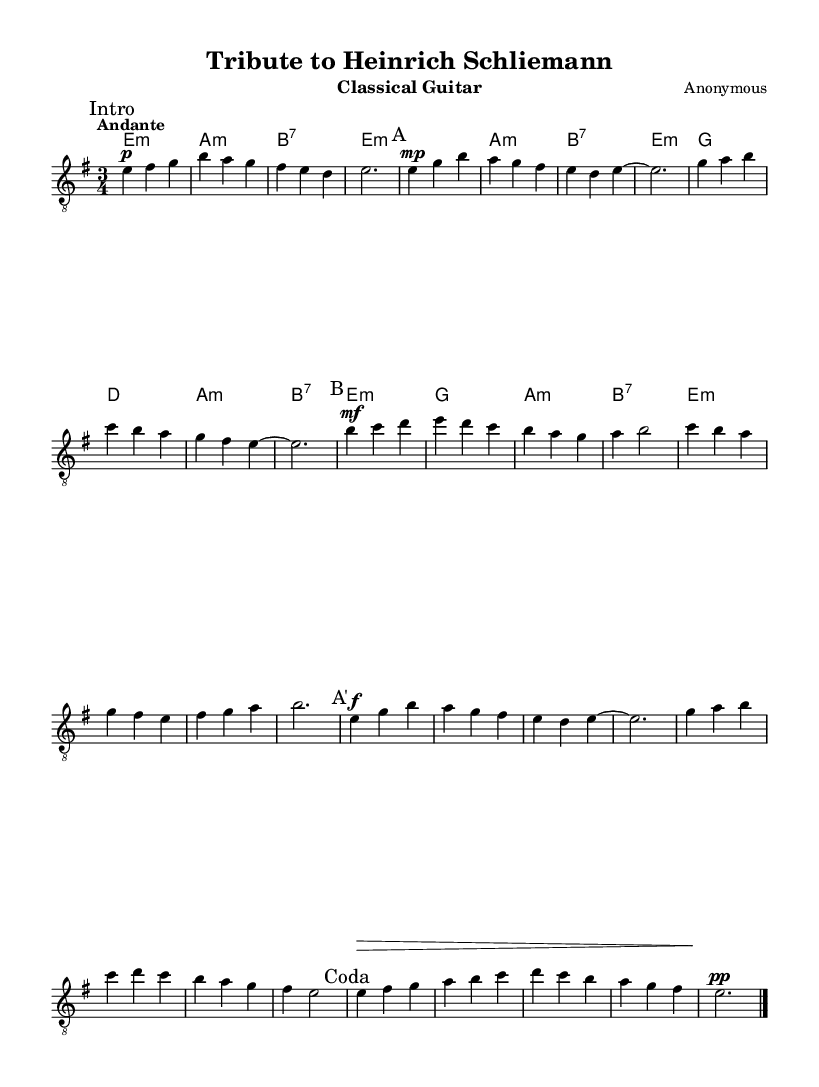What is the key signature of this music? The key signature is E minor, which has one sharp (F#). This is indicated at the beginning of the piece in the global settings.
Answer: E minor What is the time signature of this music? The time signature is 3/4, which means there are three beats in each measure with a quarter note getting the beat. This is shown in the global section as part of the settings.
Answer: 3/4 What is the tempo marking of this piece? The tempo marking is "Andante," which indicates a moderate walking pace. This is explicitly noted in the global settings under tempo.
Answer: Andante How many sections are there in this composition? There are four main sections: A, B, A', and Coda. Each section is marked in the music above the corresponding measures, providing clear labels for each part.
Answer: Four What dynamic marking appears at the beginning of the B section? The dynamic marking at the beginning of the B section is "mf," which stands for mezzo forte, indicating a moderately loud volume. This is indicated above the first note of the B section.
Answer: mf In which section does the composer employ the dynamic marking "f"? The dynamic marking "f" appears at the beginning of the A' section. It directs the performer to play this section loudly, and the marking is shown above the first note of this section.
Answer: A' What specific musical role does the figure "e2." have in this composition? The figure "e2." serves as a whole note tied over a measure, providing a tonal foundation by emphasizing the tonic in the E minor key. This is a common practice in Romantic compositions to create resolution in the harmony.
Answer: Whole note 